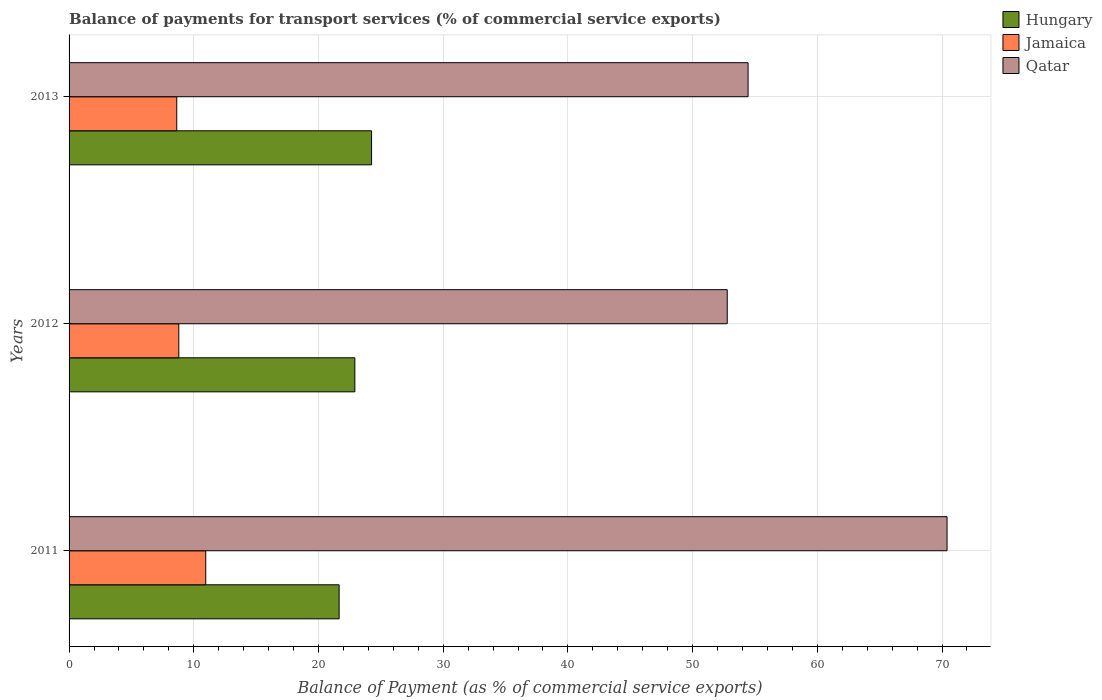What is the balance of payments for transport services in Jamaica in 2013?
Your answer should be very brief. 8.63. Across all years, what is the maximum balance of payments for transport services in Jamaica?
Your answer should be compact. 10.96. Across all years, what is the minimum balance of payments for transport services in Qatar?
Your answer should be very brief. 52.78. In which year was the balance of payments for transport services in Hungary maximum?
Your response must be concise. 2013. What is the total balance of payments for transport services in Qatar in the graph?
Offer a very short reply. 177.62. What is the difference between the balance of payments for transport services in Jamaica in 2012 and that in 2013?
Offer a very short reply. 0.17. What is the difference between the balance of payments for transport services in Hungary in 2013 and the balance of payments for transport services in Jamaica in 2012?
Provide a succinct answer. 15.46. What is the average balance of payments for transport services in Qatar per year?
Your answer should be compact. 59.21. In the year 2013, what is the difference between the balance of payments for transport services in Qatar and balance of payments for transport services in Jamaica?
Your answer should be compact. 45.81. In how many years, is the balance of payments for transport services in Qatar greater than 30 %?
Give a very brief answer. 3. What is the ratio of the balance of payments for transport services in Qatar in 2011 to that in 2013?
Your answer should be very brief. 1.29. What is the difference between the highest and the second highest balance of payments for transport services in Hungary?
Provide a succinct answer. 1.34. What is the difference between the highest and the lowest balance of payments for transport services in Jamaica?
Keep it short and to the point. 2.32. What does the 2nd bar from the top in 2011 represents?
Offer a very short reply. Jamaica. What does the 3rd bar from the bottom in 2013 represents?
Offer a terse response. Qatar. Is it the case that in every year, the sum of the balance of payments for transport services in Qatar and balance of payments for transport services in Jamaica is greater than the balance of payments for transport services in Hungary?
Provide a short and direct response. Yes. How many bars are there?
Provide a succinct answer. 9. How many years are there in the graph?
Provide a short and direct response. 3. Does the graph contain grids?
Offer a terse response. Yes. How many legend labels are there?
Ensure brevity in your answer.  3. How are the legend labels stacked?
Provide a succinct answer. Vertical. What is the title of the graph?
Keep it short and to the point. Balance of payments for transport services (% of commercial service exports). Does "High income" appear as one of the legend labels in the graph?
Offer a very short reply. No. What is the label or title of the X-axis?
Your answer should be compact. Balance of Payment (as % of commercial service exports). What is the Balance of Payment (as % of commercial service exports) in Hungary in 2011?
Your response must be concise. 21.66. What is the Balance of Payment (as % of commercial service exports) in Jamaica in 2011?
Your answer should be compact. 10.96. What is the Balance of Payment (as % of commercial service exports) of Qatar in 2011?
Make the answer very short. 70.4. What is the Balance of Payment (as % of commercial service exports) of Hungary in 2012?
Provide a short and direct response. 22.92. What is the Balance of Payment (as % of commercial service exports) in Jamaica in 2012?
Offer a very short reply. 8.8. What is the Balance of Payment (as % of commercial service exports) in Qatar in 2012?
Provide a short and direct response. 52.78. What is the Balance of Payment (as % of commercial service exports) in Hungary in 2013?
Offer a very short reply. 24.26. What is the Balance of Payment (as % of commercial service exports) of Jamaica in 2013?
Make the answer very short. 8.63. What is the Balance of Payment (as % of commercial service exports) of Qatar in 2013?
Your response must be concise. 54.45. Across all years, what is the maximum Balance of Payment (as % of commercial service exports) in Hungary?
Keep it short and to the point. 24.26. Across all years, what is the maximum Balance of Payment (as % of commercial service exports) in Jamaica?
Offer a terse response. 10.96. Across all years, what is the maximum Balance of Payment (as % of commercial service exports) in Qatar?
Make the answer very short. 70.4. Across all years, what is the minimum Balance of Payment (as % of commercial service exports) of Hungary?
Offer a very short reply. 21.66. Across all years, what is the minimum Balance of Payment (as % of commercial service exports) in Jamaica?
Ensure brevity in your answer.  8.63. Across all years, what is the minimum Balance of Payment (as % of commercial service exports) in Qatar?
Offer a very short reply. 52.78. What is the total Balance of Payment (as % of commercial service exports) in Hungary in the graph?
Offer a very short reply. 68.83. What is the total Balance of Payment (as % of commercial service exports) of Jamaica in the graph?
Make the answer very short. 28.39. What is the total Balance of Payment (as % of commercial service exports) of Qatar in the graph?
Your answer should be compact. 177.62. What is the difference between the Balance of Payment (as % of commercial service exports) in Hungary in 2011 and that in 2012?
Your response must be concise. -1.26. What is the difference between the Balance of Payment (as % of commercial service exports) of Jamaica in 2011 and that in 2012?
Offer a terse response. 2.16. What is the difference between the Balance of Payment (as % of commercial service exports) in Qatar in 2011 and that in 2012?
Offer a very short reply. 17.63. What is the difference between the Balance of Payment (as % of commercial service exports) in Hungary in 2011 and that in 2013?
Your answer should be compact. -2.6. What is the difference between the Balance of Payment (as % of commercial service exports) in Jamaica in 2011 and that in 2013?
Make the answer very short. 2.32. What is the difference between the Balance of Payment (as % of commercial service exports) in Qatar in 2011 and that in 2013?
Ensure brevity in your answer.  15.96. What is the difference between the Balance of Payment (as % of commercial service exports) in Hungary in 2012 and that in 2013?
Ensure brevity in your answer.  -1.34. What is the difference between the Balance of Payment (as % of commercial service exports) of Jamaica in 2012 and that in 2013?
Your answer should be very brief. 0.17. What is the difference between the Balance of Payment (as % of commercial service exports) in Qatar in 2012 and that in 2013?
Provide a short and direct response. -1.67. What is the difference between the Balance of Payment (as % of commercial service exports) in Hungary in 2011 and the Balance of Payment (as % of commercial service exports) in Jamaica in 2012?
Give a very brief answer. 12.86. What is the difference between the Balance of Payment (as % of commercial service exports) in Hungary in 2011 and the Balance of Payment (as % of commercial service exports) in Qatar in 2012?
Make the answer very short. -31.12. What is the difference between the Balance of Payment (as % of commercial service exports) in Jamaica in 2011 and the Balance of Payment (as % of commercial service exports) in Qatar in 2012?
Offer a very short reply. -41.82. What is the difference between the Balance of Payment (as % of commercial service exports) of Hungary in 2011 and the Balance of Payment (as % of commercial service exports) of Jamaica in 2013?
Offer a very short reply. 13.02. What is the difference between the Balance of Payment (as % of commercial service exports) of Hungary in 2011 and the Balance of Payment (as % of commercial service exports) of Qatar in 2013?
Provide a short and direct response. -32.79. What is the difference between the Balance of Payment (as % of commercial service exports) in Jamaica in 2011 and the Balance of Payment (as % of commercial service exports) in Qatar in 2013?
Offer a terse response. -43.49. What is the difference between the Balance of Payment (as % of commercial service exports) in Hungary in 2012 and the Balance of Payment (as % of commercial service exports) in Jamaica in 2013?
Offer a terse response. 14.28. What is the difference between the Balance of Payment (as % of commercial service exports) of Hungary in 2012 and the Balance of Payment (as % of commercial service exports) of Qatar in 2013?
Offer a very short reply. -31.53. What is the difference between the Balance of Payment (as % of commercial service exports) in Jamaica in 2012 and the Balance of Payment (as % of commercial service exports) in Qatar in 2013?
Keep it short and to the point. -45.65. What is the average Balance of Payment (as % of commercial service exports) in Hungary per year?
Provide a short and direct response. 22.94. What is the average Balance of Payment (as % of commercial service exports) in Jamaica per year?
Provide a succinct answer. 9.46. What is the average Balance of Payment (as % of commercial service exports) of Qatar per year?
Give a very brief answer. 59.21. In the year 2011, what is the difference between the Balance of Payment (as % of commercial service exports) in Hungary and Balance of Payment (as % of commercial service exports) in Jamaica?
Offer a terse response. 10.7. In the year 2011, what is the difference between the Balance of Payment (as % of commercial service exports) of Hungary and Balance of Payment (as % of commercial service exports) of Qatar?
Make the answer very short. -48.75. In the year 2011, what is the difference between the Balance of Payment (as % of commercial service exports) of Jamaica and Balance of Payment (as % of commercial service exports) of Qatar?
Your answer should be very brief. -59.44. In the year 2012, what is the difference between the Balance of Payment (as % of commercial service exports) of Hungary and Balance of Payment (as % of commercial service exports) of Jamaica?
Ensure brevity in your answer.  14.12. In the year 2012, what is the difference between the Balance of Payment (as % of commercial service exports) of Hungary and Balance of Payment (as % of commercial service exports) of Qatar?
Offer a terse response. -29.86. In the year 2012, what is the difference between the Balance of Payment (as % of commercial service exports) of Jamaica and Balance of Payment (as % of commercial service exports) of Qatar?
Your answer should be compact. -43.98. In the year 2013, what is the difference between the Balance of Payment (as % of commercial service exports) of Hungary and Balance of Payment (as % of commercial service exports) of Jamaica?
Your answer should be very brief. 15.62. In the year 2013, what is the difference between the Balance of Payment (as % of commercial service exports) of Hungary and Balance of Payment (as % of commercial service exports) of Qatar?
Your answer should be very brief. -30.19. In the year 2013, what is the difference between the Balance of Payment (as % of commercial service exports) of Jamaica and Balance of Payment (as % of commercial service exports) of Qatar?
Make the answer very short. -45.81. What is the ratio of the Balance of Payment (as % of commercial service exports) of Hungary in 2011 to that in 2012?
Ensure brevity in your answer.  0.94. What is the ratio of the Balance of Payment (as % of commercial service exports) in Jamaica in 2011 to that in 2012?
Your response must be concise. 1.25. What is the ratio of the Balance of Payment (as % of commercial service exports) of Qatar in 2011 to that in 2012?
Your response must be concise. 1.33. What is the ratio of the Balance of Payment (as % of commercial service exports) of Hungary in 2011 to that in 2013?
Your answer should be compact. 0.89. What is the ratio of the Balance of Payment (as % of commercial service exports) in Jamaica in 2011 to that in 2013?
Ensure brevity in your answer.  1.27. What is the ratio of the Balance of Payment (as % of commercial service exports) of Qatar in 2011 to that in 2013?
Ensure brevity in your answer.  1.29. What is the ratio of the Balance of Payment (as % of commercial service exports) of Hungary in 2012 to that in 2013?
Your response must be concise. 0.94. What is the ratio of the Balance of Payment (as % of commercial service exports) in Jamaica in 2012 to that in 2013?
Offer a terse response. 1.02. What is the ratio of the Balance of Payment (as % of commercial service exports) of Qatar in 2012 to that in 2013?
Keep it short and to the point. 0.97. What is the difference between the highest and the second highest Balance of Payment (as % of commercial service exports) in Hungary?
Provide a succinct answer. 1.34. What is the difference between the highest and the second highest Balance of Payment (as % of commercial service exports) in Jamaica?
Offer a very short reply. 2.16. What is the difference between the highest and the second highest Balance of Payment (as % of commercial service exports) of Qatar?
Your answer should be very brief. 15.96. What is the difference between the highest and the lowest Balance of Payment (as % of commercial service exports) in Hungary?
Make the answer very short. 2.6. What is the difference between the highest and the lowest Balance of Payment (as % of commercial service exports) of Jamaica?
Offer a very short reply. 2.32. What is the difference between the highest and the lowest Balance of Payment (as % of commercial service exports) of Qatar?
Give a very brief answer. 17.63. 